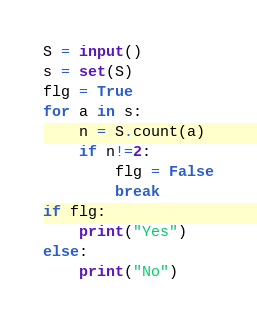Convert code to text. <code><loc_0><loc_0><loc_500><loc_500><_Python_>S = input()
s = set(S)
flg = True
for a in s:
    n = S.count(a)
    if n!=2:
        flg = False
        break
if flg:
    print("Yes")
else:
    print("No")</code> 